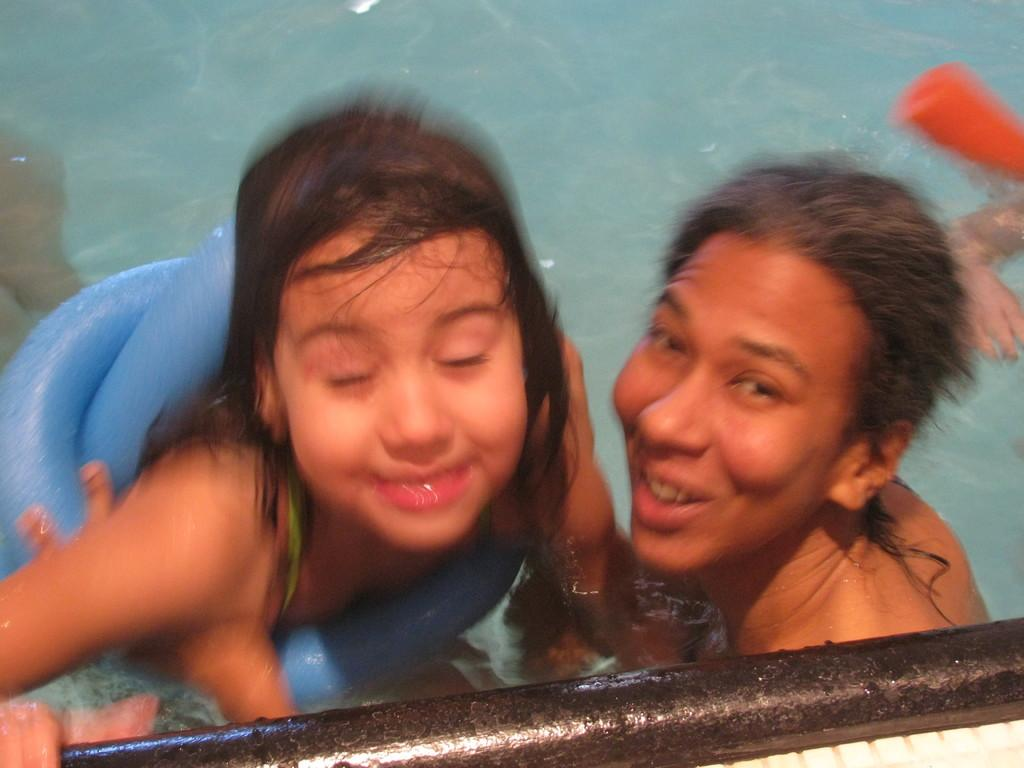Who are the people in the image? There is a girl and a man in the image. Where are the girl and the man located in the image? Both the girl and the man are in the middle of the image. What can be seen in the background of the image? There is water visible in the background of the image. What object is present at the bottom of the image? There is a rod at the bottom of the image. What type of test can be seen being conducted in the image? There is no test being conducted in the image; it features a girl and a man in the middle of the image with water visible in the background and a rod at the bottom. 